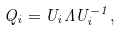<formula> <loc_0><loc_0><loc_500><loc_500>Q _ { i } = U _ { i } \Lambda U _ { i } ^ { - 1 } ,</formula> 